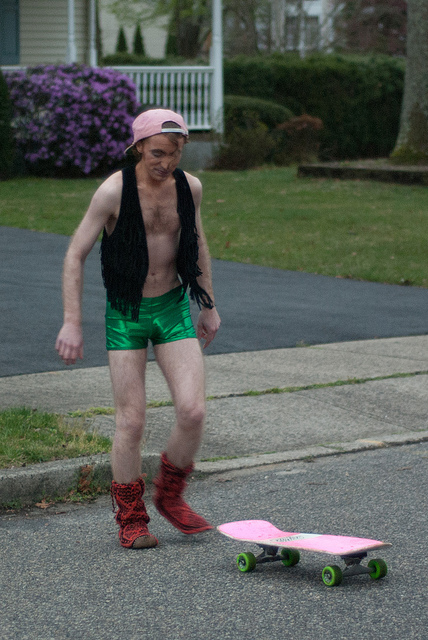<image>Which foot does the male have on the skateboard? The male may not have any foot on the skateboard. Which foot does the male have on the skateboard? I don't know which foot the male has on the skateboard. It can be neither left nor right. 